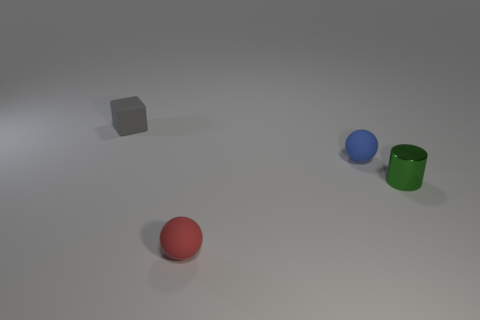Are there any other things that are the same material as the green thing?
Your answer should be very brief. No. What number of objects are in front of the tiny matte thing that is behind the blue ball?
Give a very brief answer. 3. Is the small red sphere made of the same material as the small green thing?
Offer a very short reply. No. There is a small matte object that is in front of the sphere behind the red object; what number of cubes are in front of it?
Make the answer very short. 0. What color is the tiny ball behind the red thing?
Offer a terse response. Blue. There is a tiny matte object on the right side of the tiny rubber object that is in front of the small blue rubber thing; what shape is it?
Your answer should be compact. Sphere. What number of spheres are either blue rubber objects or tiny matte objects?
Make the answer very short. 2. There is a tiny object that is behind the small red ball and in front of the blue thing; what material is it?
Make the answer very short. Metal. How many small metallic objects are in front of the cylinder?
Offer a very short reply. 0. Is the thing in front of the small cylinder made of the same material as the tiny object right of the small blue thing?
Give a very brief answer. No. 